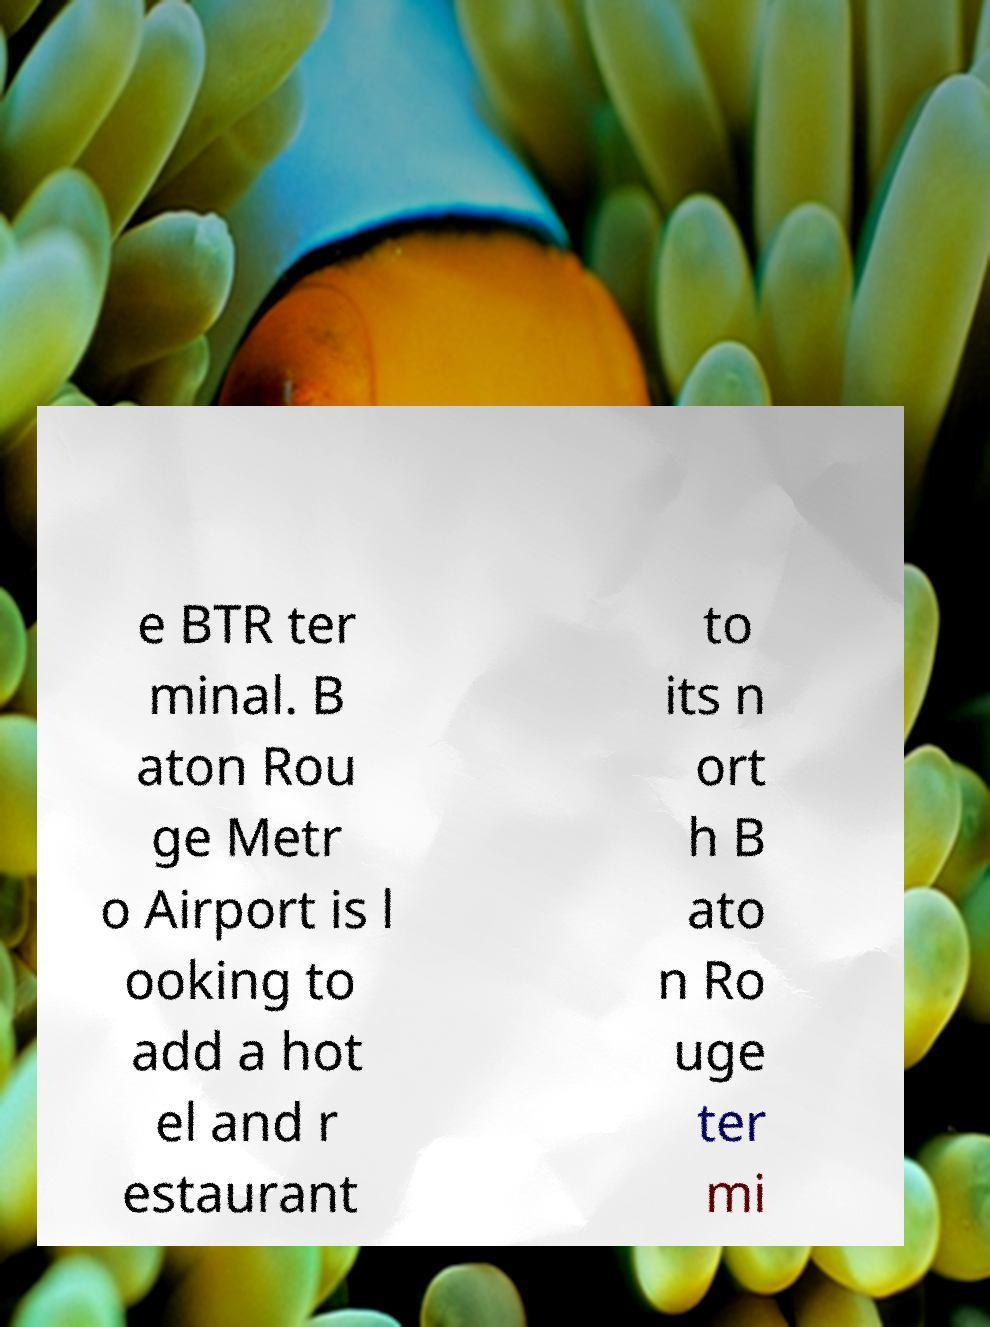Please identify and transcribe the text found in this image. e BTR ter minal. B aton Rou ge Metr o Airport is l ooking to add a hot el and r estaurant to its n ort h B ato n Ro uge ter mi 